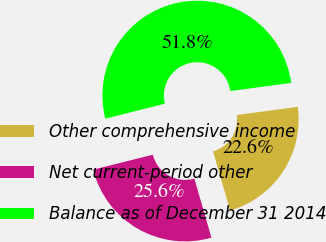Convert chart. <chart><loc_0><loc_0><loc_500><loc_500><pie_chart><fcel>Other comprehensive income<fcel>Net current-period other<fcel>Balance as of December 31 2014<nl><fcel>22.65%<fcel>25.56%<fcel>51.79%<nl></chart> 